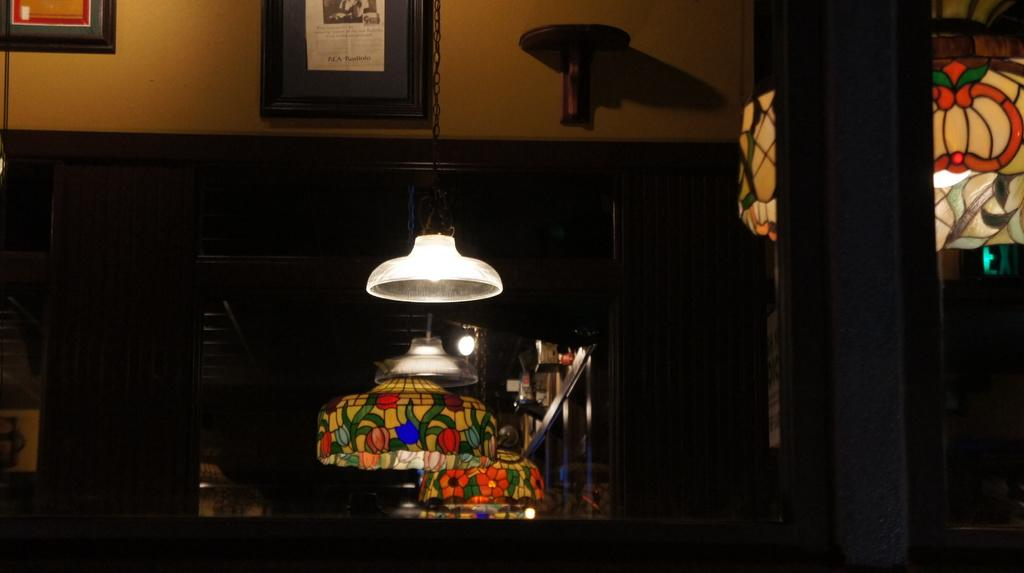What type of objects can be seen in the image that provide light? There are lamps in the image that provide light. What can be seen on the wall in the image? There is a photo frame on the wall in the image. What object in the image allows for self-reflection? There is a mirror in the image that allows for self-reflection. Can you see any quivers in the image? There is no mention of quivers in the provided facts, and therefore, we cannot determine if any are present in the image. Is there a bear in the image? There is no mention of a bear in the provided facts, and therefore, we cannot determine if one is present in the image. 